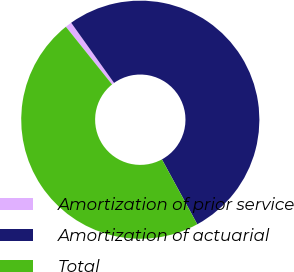Convert chart to OTSL. <chart><loc_0><loc_0><loc_500><loc_500><pie_chart><fcel>Amortization of prior service<fcel>Amortization of actuarial<fcel>Total<nl><fcel>0.89%<fcel>51.91%<fcel>47.19%<nl></chart> 